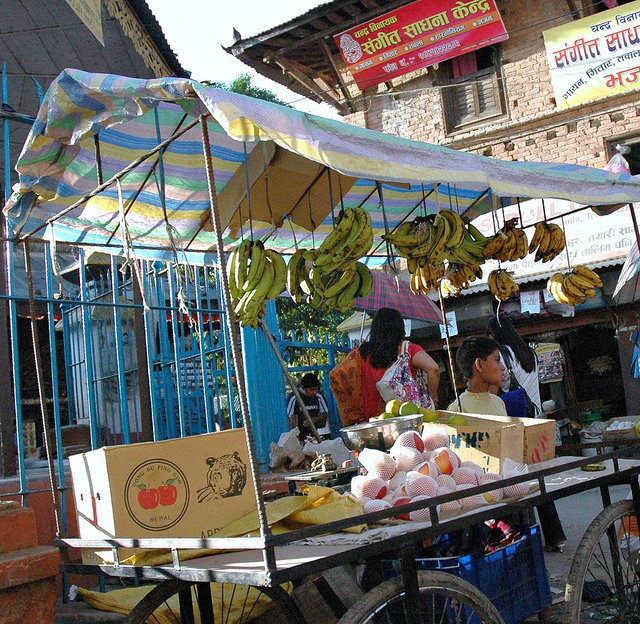<image>What does the sign say? I don't know what the sign says. It can say 'fruits', 'apples for sale', 'fresh fruit', 'cherries', 'bananas', 'fruit for sale', 'fruit' or 'market'. What does the sign say? I don't know what the sign says. It can be seen 'fruits', 'apples for sale', 'fresh fruit', 'cherries', 'bananas', 'fruit for sale', 'fruit', or 'market'. 